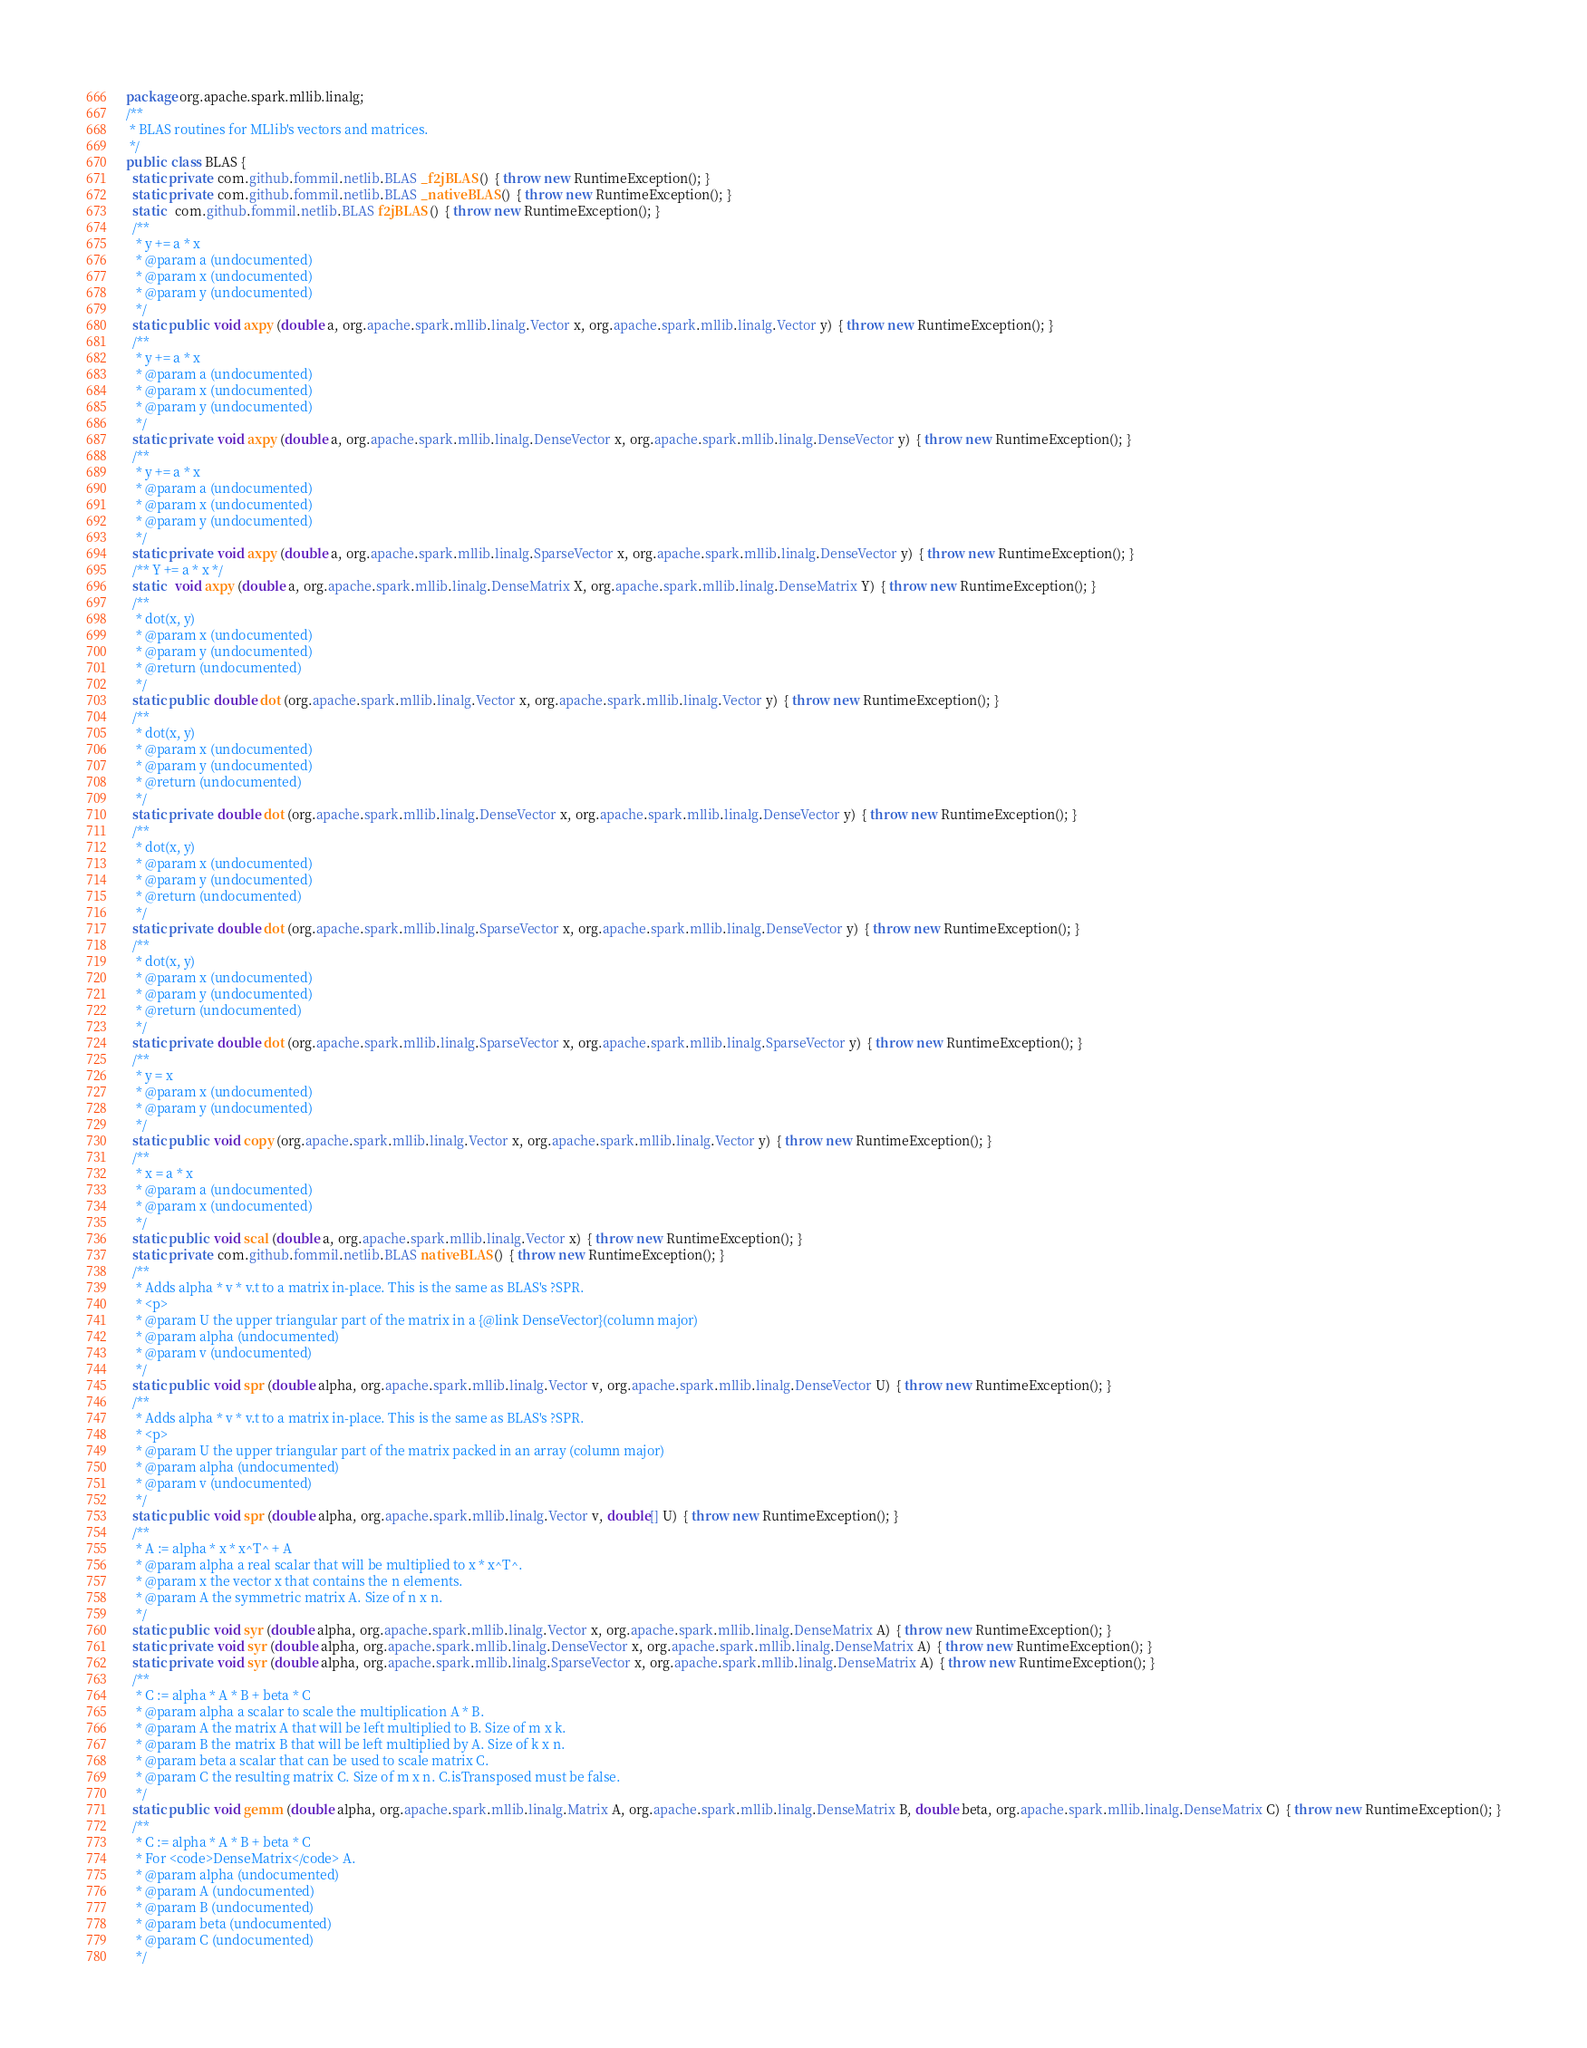Convert code to text. <code><loc_0><loc_0><loc_500><loc_500><_Java_>package org.apache.spark.mllib.linalg;
/**
 * BLAS routines for MLlib's vectors and matrices.
 */
public  class BLAS {
  static private  com.github.fommil.netlib.BLAS _f2jBLAS ()  { throw new RuntimeException(); }
  static private  com.github.fommil.netlib.BLAS _nativeBLAS ()  { throw new RuntimeException(); }
  static   com.github.fommil.netlib.BLAS f2jBLAS ()  { throw new RuntimeException(); }
  /**
   * y += a * x
   * @param a (undocumented)
   * @param x (undocumented)
   * @param y (undocumented)
   */
  static public  void axpy (double a, org.apache.spark.mllib.linalg.Vector x, org.apache.spark.mllib.linalg.Vector y)  { throw new RuntimeException(); }
  /**
   * y += a * x
   * @param a (undocumented)
   * @param x (undocumented)
   * @param y (undocumented)
   */
  static private  void axpy (double a, org.apache.spark.mllib.linalg.DenseVector x, org.apache.spark.mllib.linalg.DenseVector y)  { throw new RuntimeException(); }
  /**
   * y += a * x
   * @param a (undocumented)
   * @param x (undocumented)
   * @param y (undocumented)
   */
  static private  void axpy (double a, org.apache.spark.mllib.linalg.SparseVector x, org.apache.spark.mllib.linalg.DenseVector y)  { throw new RuntimeException(); }
  /** Y += a * x */
  static   void axpy (double a, org.apache.spark.mllib.linalg.DenseMatrix X, org.apache.spark.mllib.linalg.DenseMatrix Y)  { throw new RuntimeException(); }
  /**
   * dot(x, y)
   * @param x (undocumented)
   * @param y (undocumented)
   * @return (undocumented)
   */
  static public  double dot (org.apache.spark.mllib.linalg.Vector x, org.apache.spark.mllib.linalg.Vector y)  { throw new RuntimeException(); }
  /**
   * dot(x, y)
   * @param x (undocumented)
   * @param y (undocumented)
   * @return (undocumented)
   */
  static private  double dot (org.apache.spark.mllib.linalg.DenseVector x, org.apache.spark.mllib.linalg.DenseVector y)  { throw new RuntimeException(); }
  /**
   * dot(x, y)
   * @param x (undocumented)
   * @param y (undocumented)
   * @return (undocumented)
   */
  static private  double dot (org.apache.spark.mllib.linalg.SparseVector x, org.apache.spark.mllib.linalg.DenseVector y)  { throw new RuntimeException(); }
  /**
   * dot(x, y)
   * @param x (undocumented)
   * @param y (undocumented)
   * @return (undocumented)
   */
  static private  double dot (org.apache.spark.mllib.linalg.SparseVector x, org.apache.spark.mllib.linalg.SparseVector y)  { throw new RuntimeException(); }
  /**
   * y = x
   * @param x (undocumented)
   * @param y (undocumented)
   */
  static public  void copy (org.apache.spark.mllib.linalg.Vector x, org.apache.spark.mllib.linalg.Vector y)  { throw new RuntimeException(); }
  /**
   * x = a * x
   * @param a (undocumented)
   * @param x (undocumented)
   */
  static public  void scal (double a, org.apache.spark.mllib.linalg.Vector x)  { throw new RuntimeException(); }
  static private  com.github.fommil.netlib.BLAS nativeBLAS ()  { throw new RuntimeException(); }
  /**
   * Adds alpha * v * v.t to a matrix in-place. This is the same as BLAS's ?SPR.
   * <p>
   * @param U the upper triangular part of the matrix in a {@link DenseVector}(column major)
   * @param alpha (undocumented)
   * @param v (undocumented)
   */
  static public  void spr (double alpha, org.apache.spark.mllib.linalg.Vector v, org.apache.spark.mllib.linalg.DenseVector U)  { throw new RuntimeException(); }
  /**
   * Adds alpha * v * v.t to a matrix in-place. This is the same as BLAS's ?SPR.
   * <p>
   * @param U the upper triangular part of the matrix packed in an array (column major)
   * @param alpha (undocumented)
   * @param v (undocumented)
   */
  static public  void spr (double alpha, org.apache.spark.mllib.linalg.Vector v, double[] U)  { throw new RuntimeException(); }
  /**
   * A := alpha * x * x^T^ + A
   * @param alpha a real scalar that will be multiplied to x * x^T^.
   * @param x the vector x that contains the n elements.
   * @param A the symmetric matrix A. Size of n x n.
   */
  static public  void syr (double alpha, org.apache.spark.mllib.linalg.Vector x, org.apache.spark.mllib.linalg.DenseMatrix A)  { throw new RuntimeException(); }
  static private  void syr (double alpha, org.apache.spark.mllib.linalg.DenseVector x, org.apache.spark.mllib.linalg.DenseMatrix A)  { throw new RuntimeException(); }
  static private  void syr (double alpha, org.apache.spark.mllib.linalg.SparseVector x, org.apache.spark.mllib.linalg.DenseMatrix A)  { throw new RuntimeException(); }
  /**
   * C := alpha * A * B + beta * C
   * @param alpha a scalar to scale the multiplication A * B.
   * @param A the matrix A that will be left multiplied to B. Size of m x k.
   * @param B the matrix B that will be left multiplied by A. Size of k x n.
   * @param beta a scalar that can be used to scale matrix C.
   * @param C the resulting matrix C. Size of m x n. C.isTransposed must be false.
   */
  static public  void gemm (double alpha, org.apache.spark.mllib.linalg.Matrix A, org.apache.spark.mllib.linalg.DenseMatrix B, double beta, org.apache.spark.mllib.linalg.DenseMatrix C)  { throw new RuntimeException(); }
  /**
   * C := alpha * A * B + beta * C
   * For <code>DenseMatrix</code> A.
   * @param alpha (undocumented)
   * @param A (undocumented)
   * @param B (undocumented)
   * @param beta (undocumented)
   * @param C (undocumented)
   */</code> 